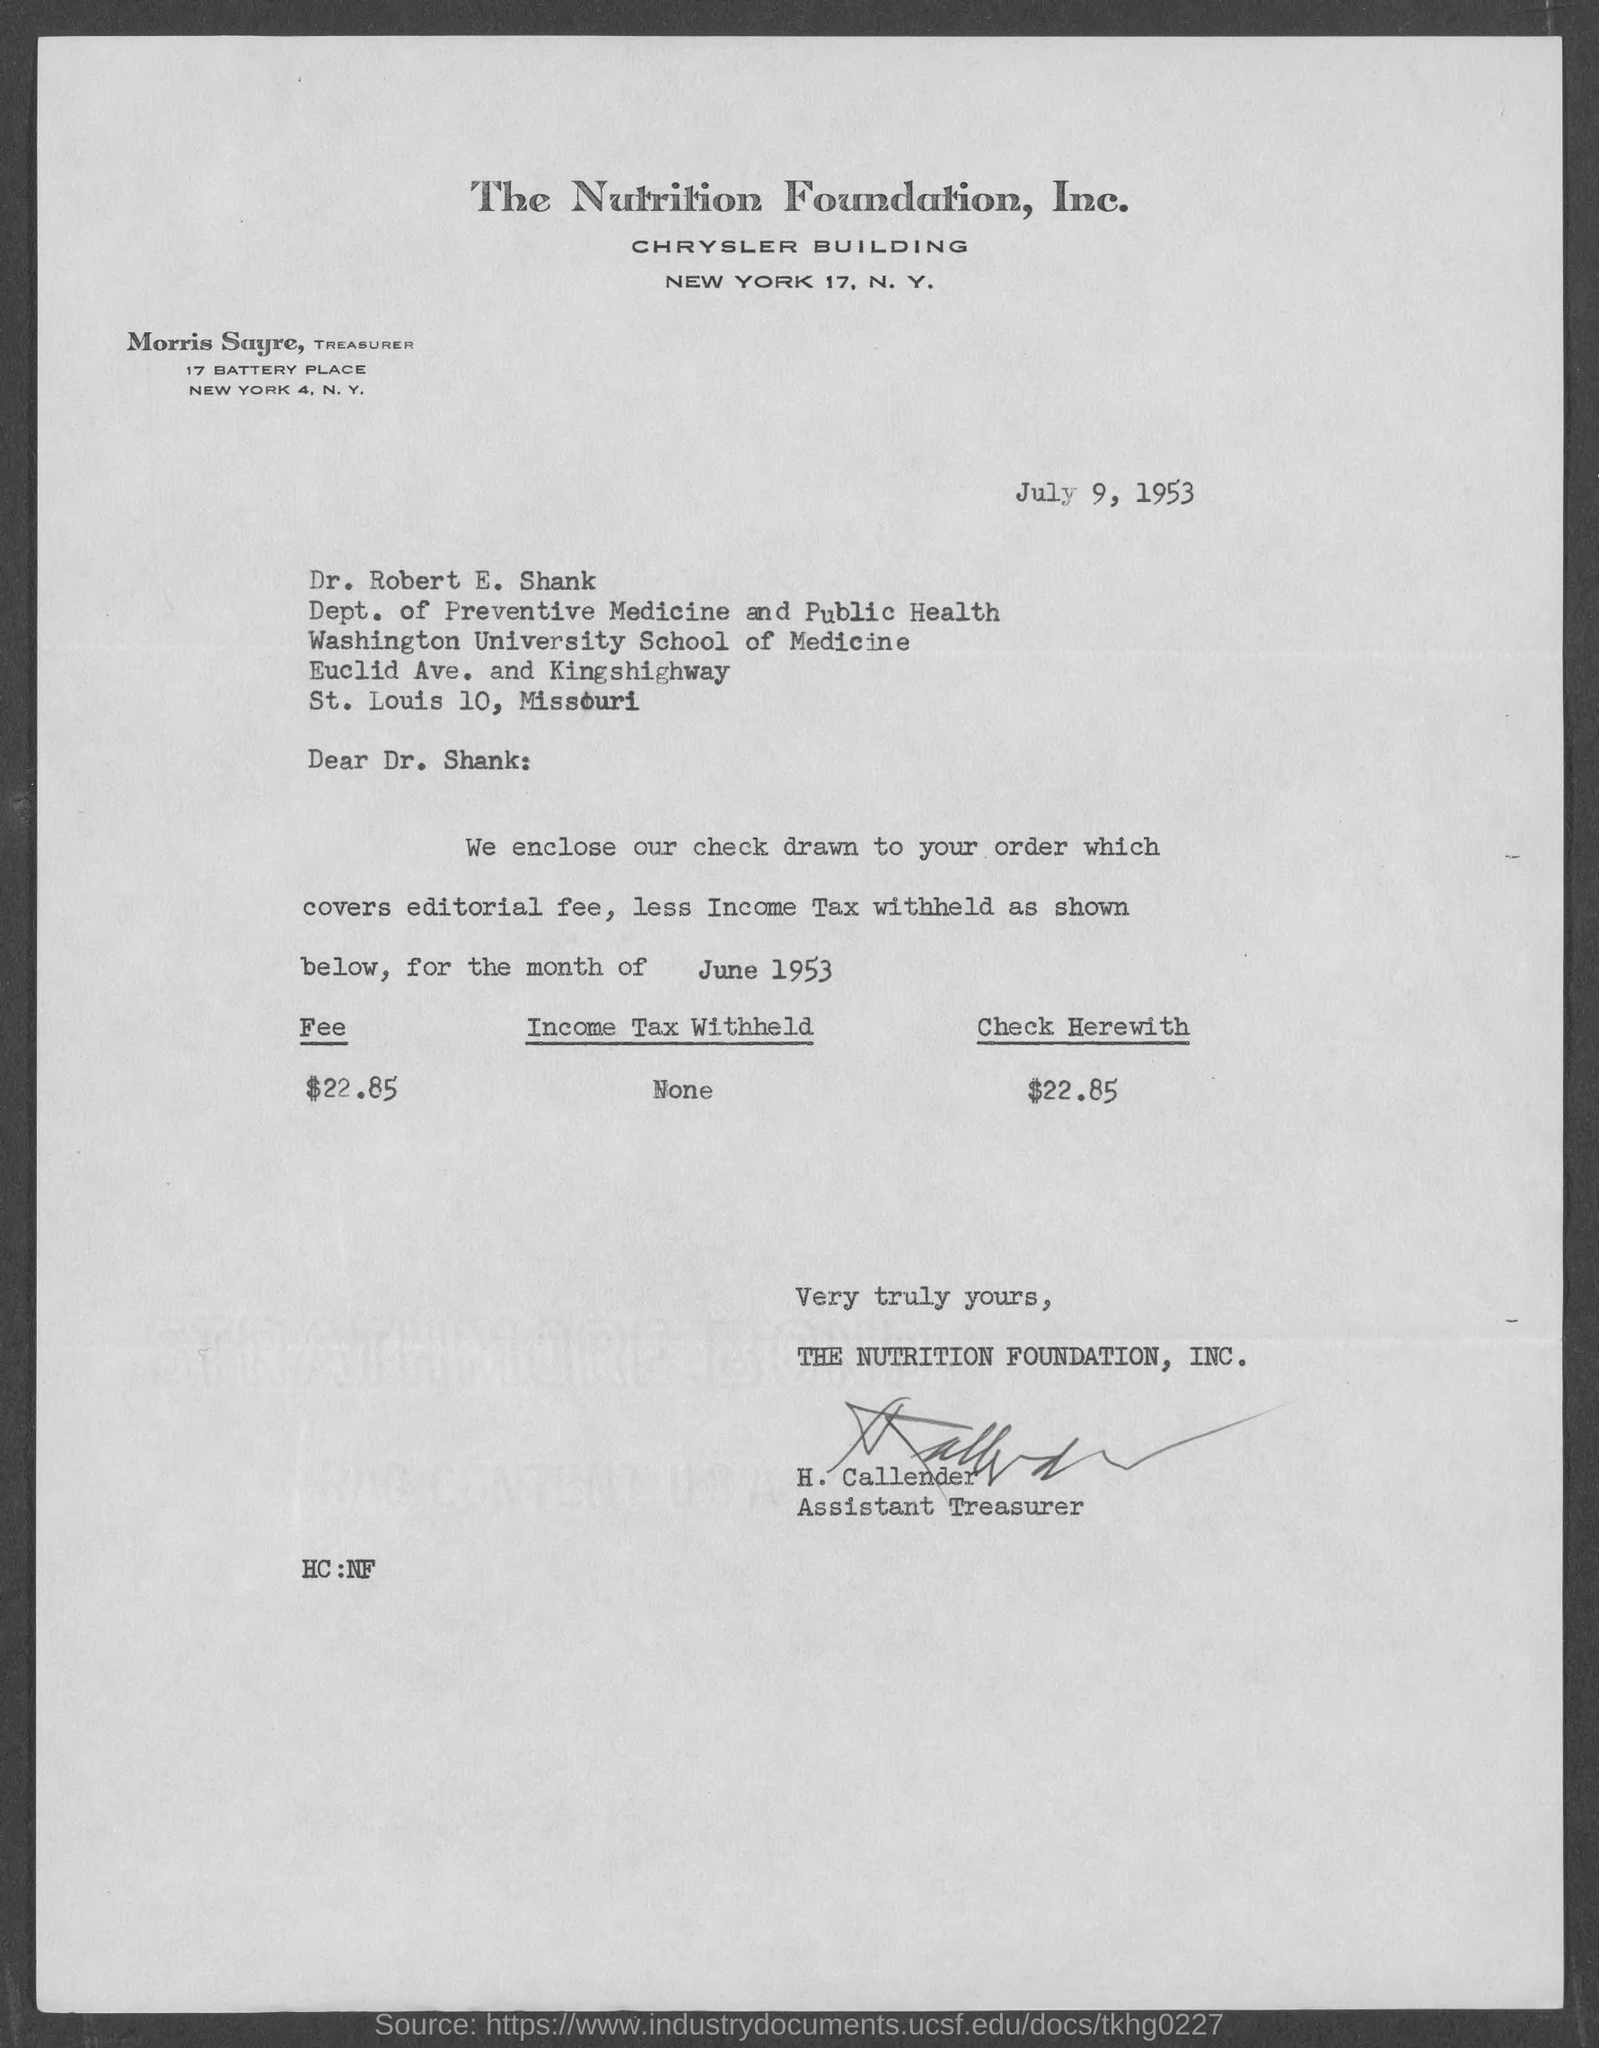Highlight a few significant elements in this photo. The letter is addressed to Dr. Robert E. Shank. The document is dated July 9, 1953. The letter is from a person named H. Callender. In June 1953, the fee was 22.85. 